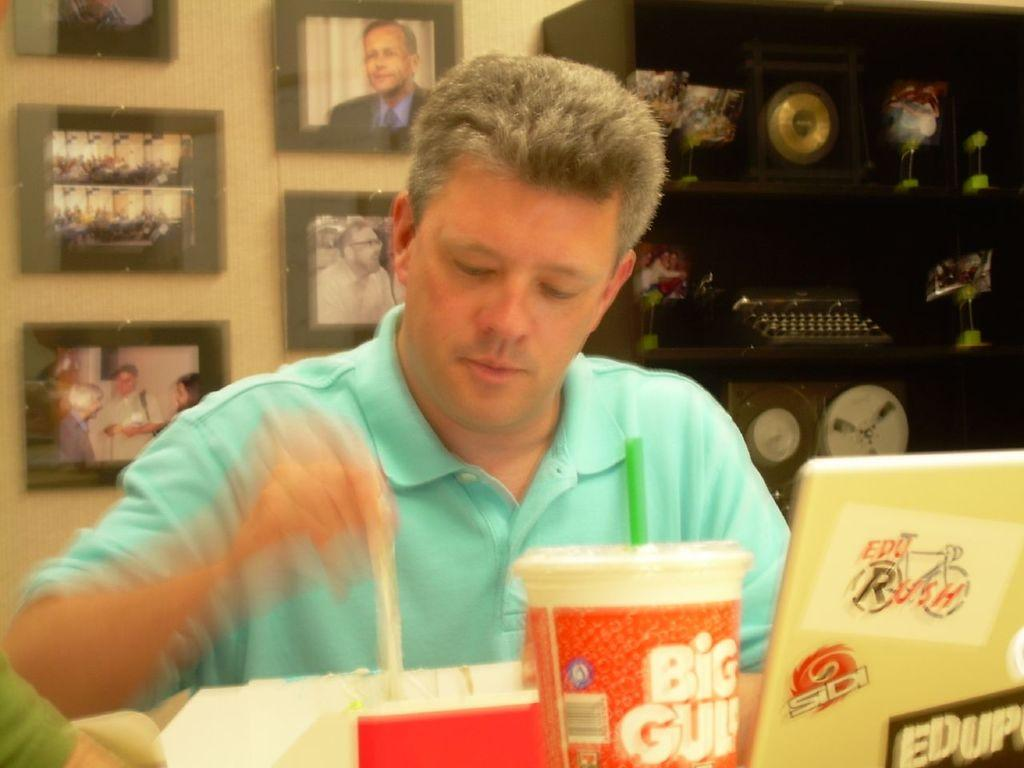<image>
Render a clear and concise summary of the photo. A Big Gulp several inches away awaits consumption as a man works on his computer. 